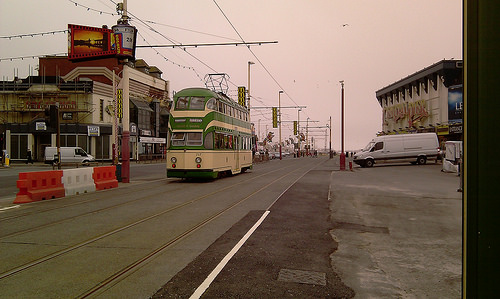<image>
Can you confirm if the van is behind the road? No. The van is not behind the road. From this viewpoint, the van appears to be positioned elsewhere in the scene. Is the bus in the road? Yes. The bus is contained within or inside the road, showing a containment relationship. 